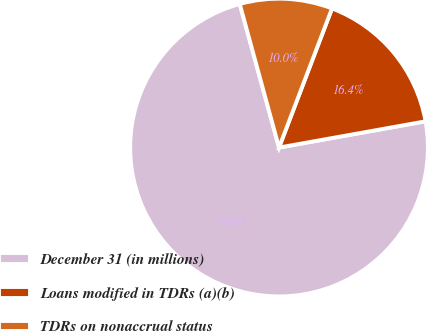<chart> <loc_0><loc_0><loc_500><loc_500><pie_chart><fcel>December 31 (in millions)<fcel>Loans modified in TDRs (a)(b)<fcel>TDRs on nonaccrual status<nl><fcel>73.57%<fcel>16.39%<fcel>10.04%<nl></chart> 